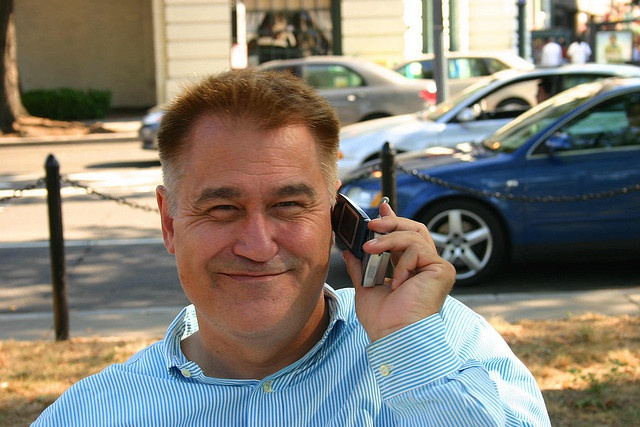Describe the objects in this image and their specific colors. I can see people in black, brown, white, and maroon tones, car in black, navy, gray, and blue tones, car in black, white, lightblue, and darkgray tones, car in black, gray, darkgray, and ivory tones, and car in black, ivory, beige, gray, and olive tones in this image. 